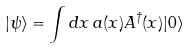Convert formula to latex. <formula><loc_0><loc_0><loc_500><loc_500>| \psi \rangle = \int d x \, a ( x ) A ^ { \dag } ( x ) | 0 \rangle</formula> 